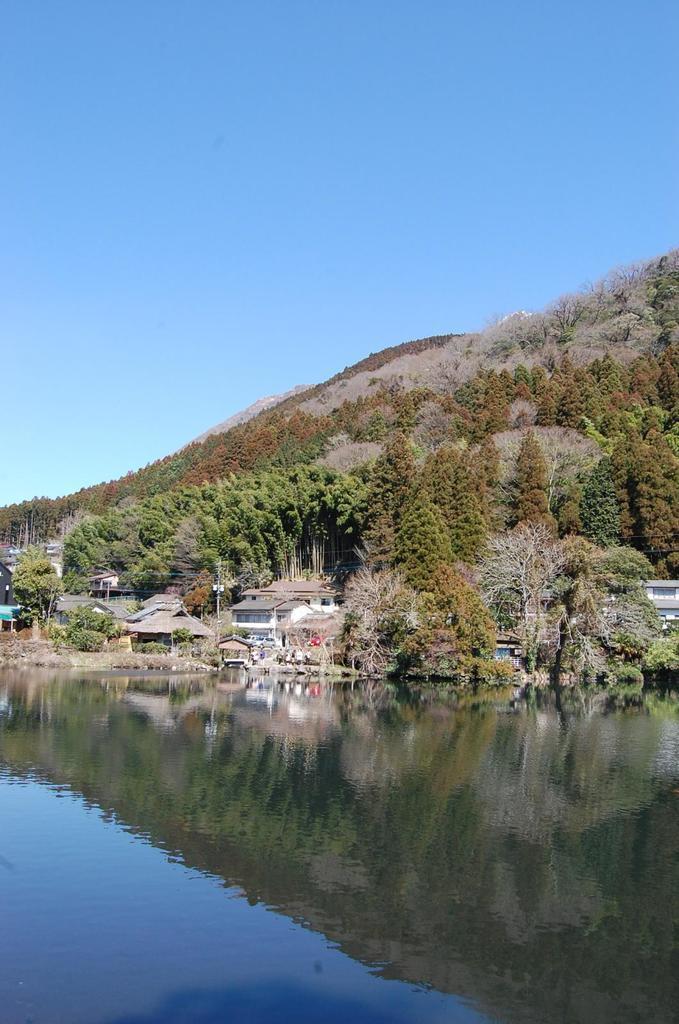Can you describe this image briefly? In this image I can see the water, few buildings, few trees and the mountain. In the background I can see the sky. 